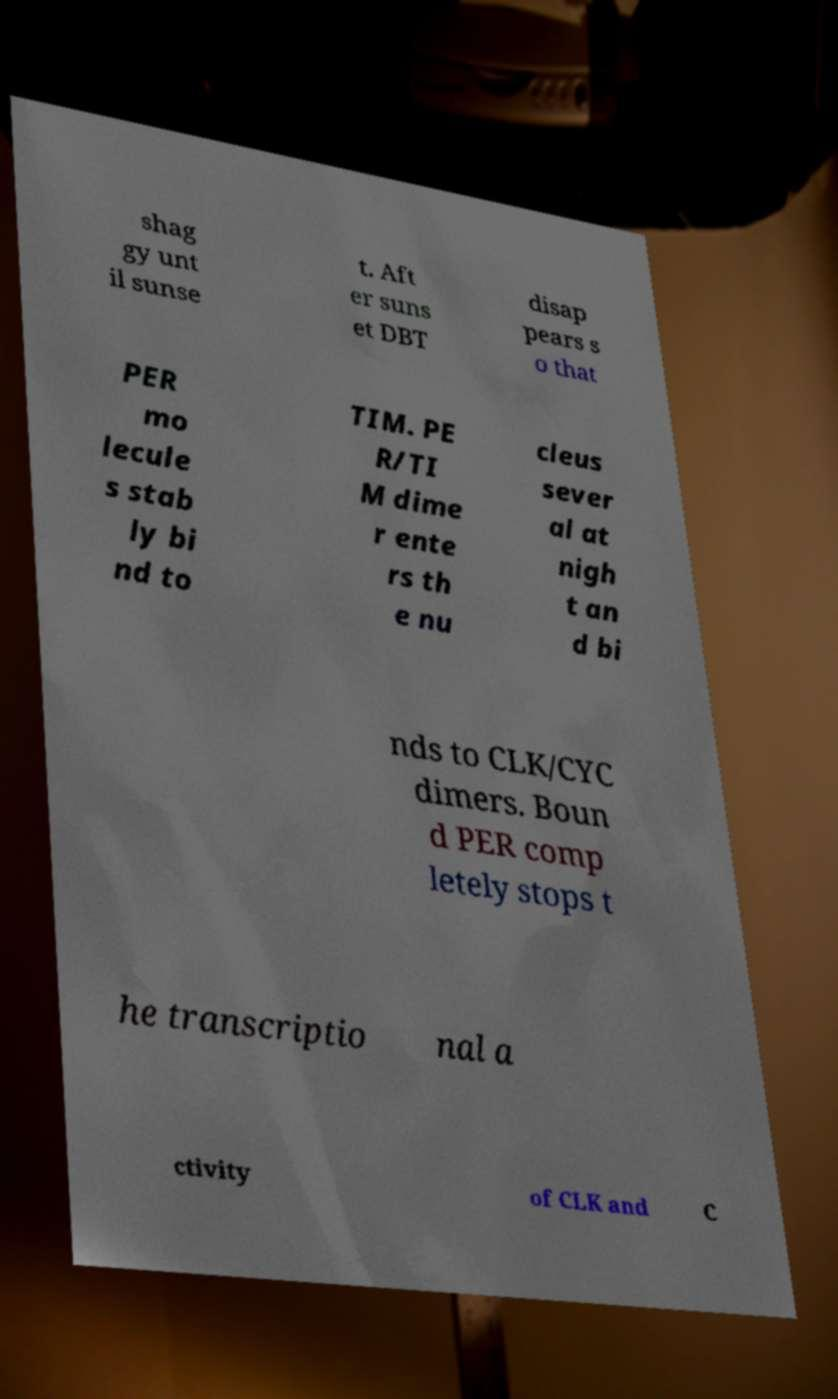Please read and relay the text visible in this image. What does it say? shag gy unt il sunse t. Aft er suns et DBT disap pears s o that PER mo lecule s stab ly bi nd to TIM. PE R/TI M dime r ente rs th e nu cleus sever al at nigh t an d bi nds to CLK/CYC dimers. Boun d PER comp letely stops t he transcriptio nal a ctivity of CLK and C 